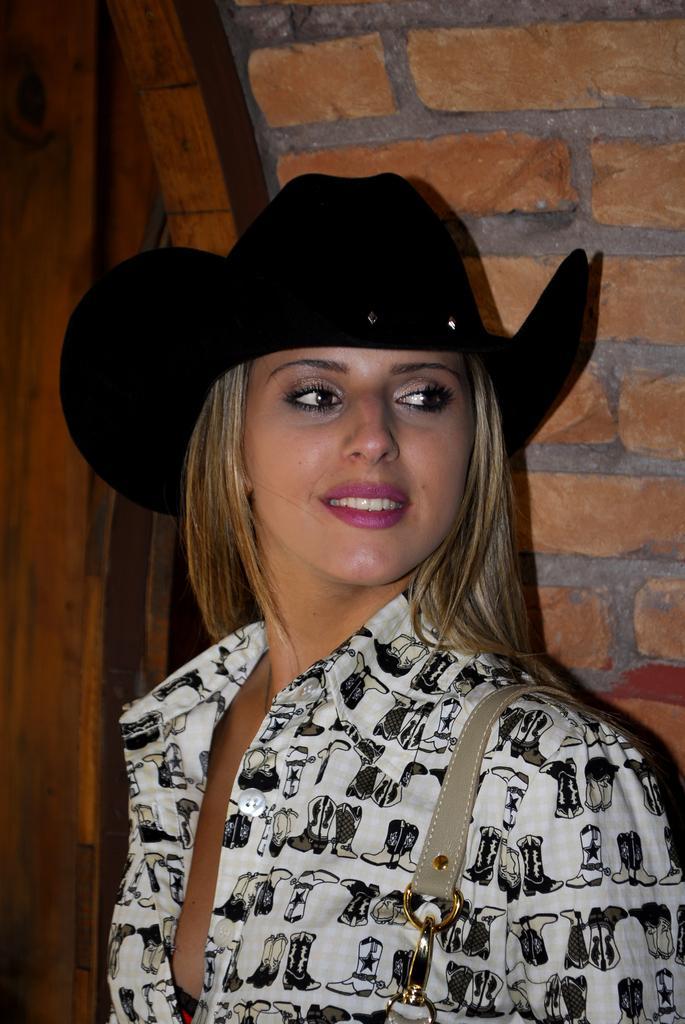Can you describe this image briefly? In the foreground of this picture, there is a beautiful woman standing and having smile on her face and she is also wearing a black hat. In the background, there is a wall and a door. 